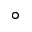Convert formula to latex. <formula><loc_0><loc_0><loc_500><loc_500>^ { \circ }</formula> 